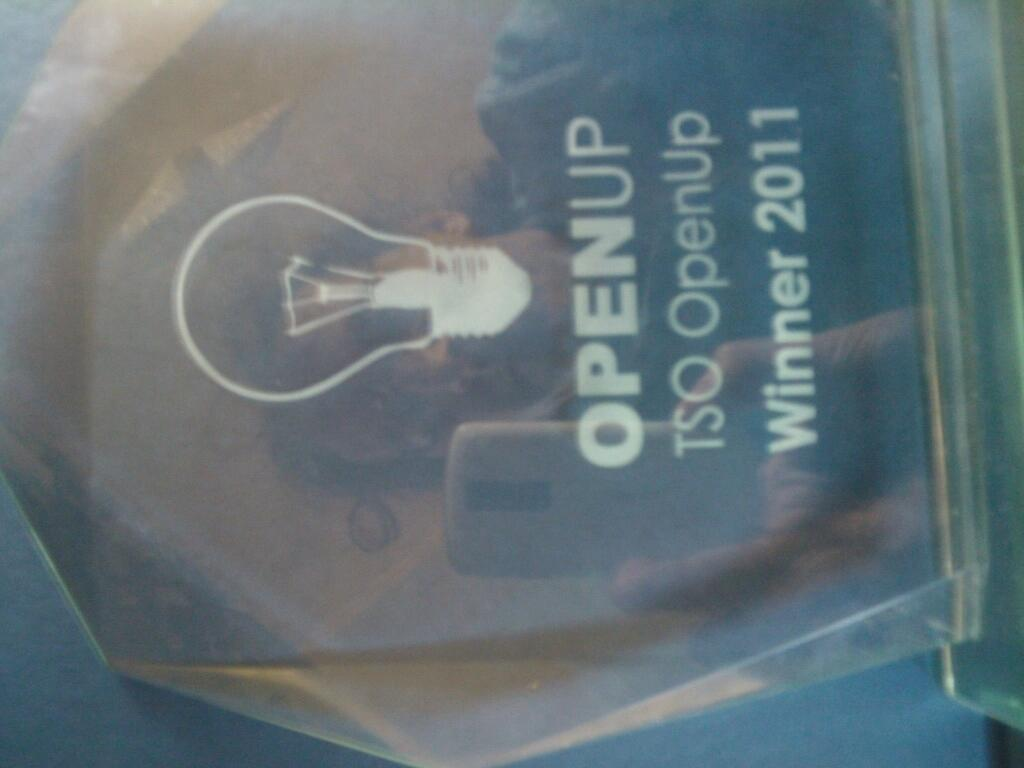<image>
Share a concise interpretation of the image provided. A translucent, angular OpenUP trophy for 2011 winners. 